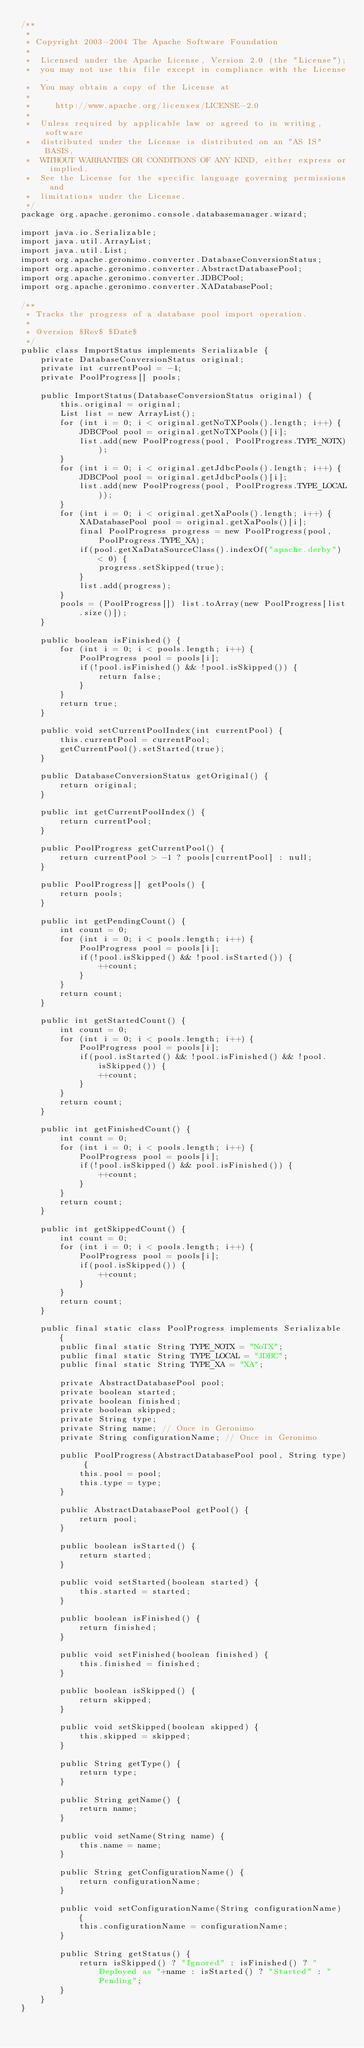<code> <loc_0><loc_0><loc_500><loc_500><_Java_>/**
 *
 * Copyright 2003-2004 The Apache Software Foundation
 *
 *  Licensed under the Apache License, Version 2.0 (the "License");
 *  you may not use this file except in compliance with the License.
 *  You may obtain a copy of the License at
 *
 *     http://www.apache.org/licenses/LICENSE-2.0
 *
 *  Unless required by applicable law or agreed to in writing, software
 *  distributed under the License is distributed on an "AS IS" BASIS,
 *  WITHOUT WARRANTIES OR CONDITIONS OF ANY KIND, either express or implied.
 *  See the License for the specific language governing permissions and
 *  limitations under the License.
 */
package org.apache.geronimo.console.databasemanager.wizard;

import java.io.Serializable;
import java.util.ArrayList;
import java.util.List;
import org.apache.geronimo.converter.DatabaseConversionStatus;
import org.apache.geronimo.converter.AbstractDatabasePool;
import org.apache.geronimo.converter.JDBCPool;
import org.apache.geronimo.converter.XADatabasePool;

/**
 * Tracks the progress of a database pool import operation.
 *
 * @version $Rev$ $Date$
 */
public class ImportStatus implements Serializable {
    private DatabaseConversionStatus original;
    private int currentPool = -1;
    private PoolProgress[] pools;

    public ImportStatus(DatabaseConversionStatus original) {
        this.original = original;
        List list = new ArrayList();
        for (int i = 0; i < original.getNoTXPools().length; i++) {
            JDBCPool pool = original.getNoTXPools()[i];
            list.add(new PoolProgress(pool, PoolProgress.TYPE_NOTX));
        }
        for (int i = 0; i < original.getJdbcPools().length; i++) {
            JDBCPool pool = original.getJdbcPools()[i];
            list.add(new PoolProgress(pool, PoolProgress.TYPE_LOCAL));
        }
        for (int i = 0; i < original.getXaPools().length; i++) {
            XADatabasePool pool = original.getXaPools()[i];
            final PoolProgress progress = new PoolProgress(pool, PoolProgress.TYPE_XA);
            if(pool.getXaDataSourceClass().indexOf("apache.derby") < 0) {
                progress.setSkipped(true);
            }
            list.add(progress);
        }
        pools = (PoolProgress[]) list.toArray(new PoolProgress[list.size()]);
    }

    public boolean isFinished() {
        for (int i = 0; i < pools.length; i++) {
            PoolProgress pool = pools[i];
            if(!pool.isFinished() && !pool.isSkipped()) {
                return false;
            }
        }
        return true;
    }

    public void setCurrentPoolIndex(int currentPool) {
        this.currentPool = currentPool;
        getCurrentPool().setStarted(true);
    }

    public DatabaseConversionStatus getOriginal() {
        return original;
    }

    public int getCurrentPoolIndex() {
        return currentPool;
    }

    public PoolProgress getCurrentPool() {
        return currentPool > -1 ? pools[currentPool] : null;
    }

    public PoolProgress[] getPools() {
        return pools;
    }

    public int getPendingCount() {
        int count = 0;
        for (int i = 0; i < pools.length; i++) {
            PoolProgress pool = pools[i];
            if(!pool.isSkipped() && !pool.isStarted()) {
                ++count;
            }
        }
        return count;
    }

    public int getStartedCount() {
        int count = 0;
        for (int i = 0; i < pools.length; i++) {
            PoolProgress pool = pools[i];
            if(pool.isStarted() && !pool.isFinished() && !pool.isSkipped()) {
                ++count;
            }
        }
        return count;
    }

    public int getFinishedCount() {
        int count = 0;
        for (int i = 0; i < pools.length; i++) {
            PoolProgress pool = pools[i];
            if(!pool.isSkipped() && pool.isFinished()) {
                ++count;
            }
        }
        return count;
    }

    public int getSkippedCount() {
        int count = 0;
        for (int i = 0; i < pools.length; i++) {
            PoolProgress pool = pools[i];
            if(pool.isSkipped()) {
                ++count;
            }
        }
        return count;
    }

    public final static class PoolProgress implements Serializable {
        public final static String TYPE_NOTX = "NoTX";
        public final static String TYPE_LOCAL = "JDBC";
        public final static String TYPE_XA = "XA";

        private AbstractDatabasePool pool;
        private boolean started;
        private boolean finished;
        private boolean skipped;
        private String type;
        private String name; // Once in Geronimo
        private String configurationName; // Once in Geronimo

        public PoolProgress(AbstractDatabasePool pool, String type) {
            this.pool = pool;
            this.type = type;
        }

        public AbstractDatabasePool getPool() {
            return pool;
        }

        public boolean isStarted() {
            return started;
        }

        public void setStarted(boolean started) {
            this.started = started;
        }

        public boolean isFinished() {
            return finished;
        }

        public void setFinished(boolean finished) {
            this.finished = finished;
        }

        public boolean isSkipped() {
            return skipped;
        }

        public void setSkipped(boolean skipped) {
            this.skipped = skipped;
        }

        public String getType() {
            return type;
        }

        public String getName() {
            return name;
        }

        public void setName(String name) {
            this.name = name;
        }

        public String getConfigurationName() {
            return configurationName;
        }

        public void setConfigurationName(String configurationName) {
            this.configurationName = configurationName;
        }

        public String getStatus() {
            return isSkipped() ? "Ignored" : isFinished() ? "Deployed as "+name : isStarted() ? "Started" : "Pending";
        }
    }
}
</code> 